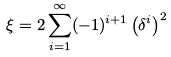<formula> <loc_0><loc_0><loc_500><loc_500>\xi = 2 \sum _ { i = 1 } ^ { \infty } ( - 1 ) ^ { i + 1 } \left ( \delta ^ { i } \right ) ^ { 2 }</formula> 